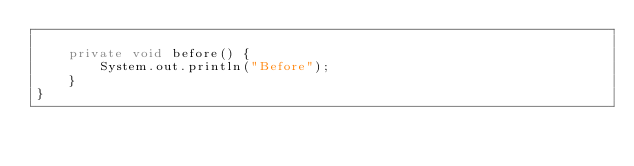<code> <loc_0><loc_0><loc_500><loc_500><_Java_>
    private void before() {
        System.out.println("Before");
    }
}
</code> 